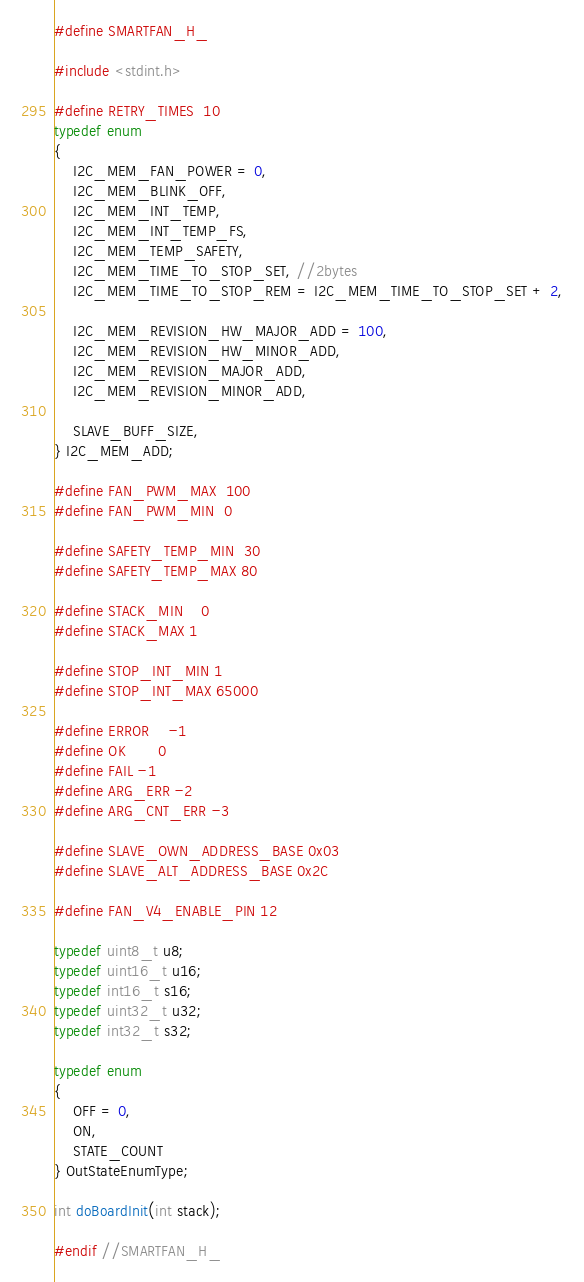<code> <loc_0><loc_0><loc_500><loc_500><_C_>#define SMARTFAN_H_

#include <stdint.h>

#define RETRY_TIMES	10
typedef enum
{
	I2C_MEM_FAN_POWER = 0,
	I2C_MEM_BLINK_OFF,
	I2C_MEM_INT_TEMP,
	I2C_MEM_INT_TEMP_FS,
	I2C_MEM_TEMP_SAFETY,
	I2C_MEM_TIME_TO_STOP_SET, //2bytes
	I2C_MEM_TIME_TO_STOP_REM = I2C_MEM_TIME_TO_STOP_SET + 2,

	I2C_MEM_REVISION_HW_MAJOR_ADD = 100,
	I2C_MEM_REVISION_HW_MINOR_ADD,
	I2C_MEM_REVISION_MAJOR_ADD,
	I2C_MEM_REVISION_MINOR_ADD,

	SLAVE_BUFF_SIZE,
} I2C_MEM_ADD;

#define FAN_PWM_MAX	100
#define FAN_PWM_MIN	0

#define SAFETY_TEMP_MIN	30
#define SAFETY_TEMP_MAX 80

#define STACK_MIN	0
#define STACK_MAX 1

#define STOP_INT_MIN	1
#define STOP_INT_MAX 65000

#define ERROR	-1
#define OK		0
#define FAIL	-1
#define ARG_ERR -2
#define ARG_CNT_ERR -3

#define SLAVE_OWN_ADDRESS_BASE 0x03
#define SLAVE_ALT_ADDRESS_BASE 0x2C

#define FAN_V4_ENABLE_PIN 12

typedef uint8_t u8;
typedef uint16_t u16;
typedef int16_t s16;
typedef uint32_t u32;
typedef int32_t s32;

typedef enum
{
	OFF = 0,
	ON,
	STATE_COUNT
} OutStateEnumType;

int doBoardInit(int stack);

#endif //SMARTFAN_H_
</code> 